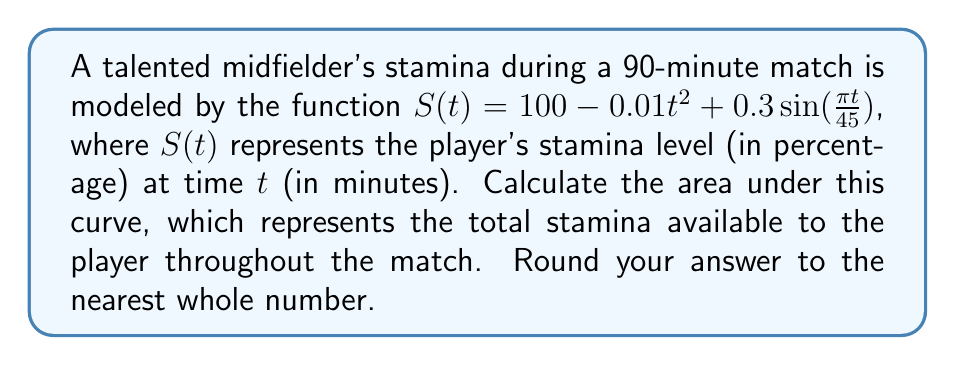Provide a solution to this math problem. To find the area under the curve, we need to integrate the function $S(t)$ from $t=0$ to $t=90$:

$$A = \int_0^{90} (100 - 0.01t^2 + 0.3\sin(\frac{\pi t}{45})) dt$$

Let's break this down step-by-step:

1) Integrate the constant term:
   $$\int_0^{90} 100 dt = 100t \bigg|_0^{90} = 9000$$

2) Integrate the quadratic term:
   $$\int_0^{90} -0.01t^2 dt = -\frac{0.01t^3}{3} \bigg|_0^{90} = -\frac{0.01(90^3)}{3} = -2430$$

3) Integrate the sinusoidal term:
   $$\int_0^{90} 0.3\sin(\frac{\pi t}{45}) dt = -0.3 \cdot \frac{45}{\pi} \cos(\frac{\pi t}{45}) \bigg|_0^{90}$$
   $$= -\frac{13.5}{\pi} [\cos(2\pi) - \cos(0)] = 0$$

4) Sum up all the parts:
   $$A = 9000 - 2430 + 0 = 6570$$

5) Round to the nearest whole number:
   $$A \approx 6570$$

This result represents the total stamina available to the player throughout the 90-minute match, considering both the gradual decline and the periodic fluctuations in their energy levels.
Answer: 6570 